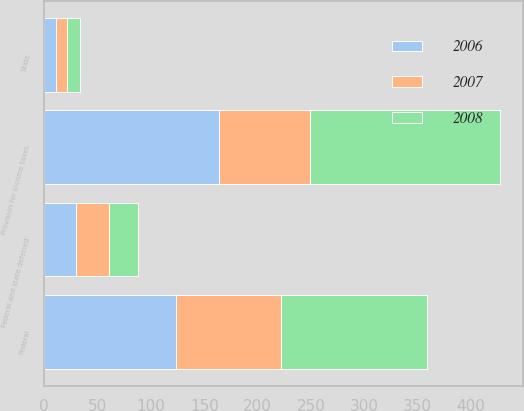Convert chart. <chart><loc_0><loc_0><loc_500><loc_500><stacked_bar_chart><ecel><fcel>Federal<fcel>State<fcel>Federal and state deferred<fcel>Provision for income taxes<nl><fcel>2007<fcel>98.1<fcel>11.1<fcel>30.4<fcel>85.4<nl><fcel>2008<fcel>136.8<fcel>12.1<fcel>27.8<fcel>177.9<nl><fcel>2006<fcel>123.6<fcel>10.6<fcel>29.9<fcel>164.1<nl></chart> 